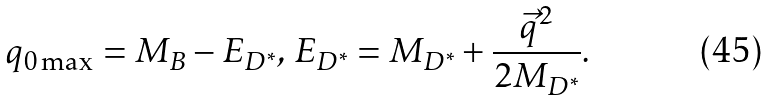Convert formula to latex. <formula><loc_0><loc_0><loc_500><loc_500>q _ { 0 \max } = M _ { B } - E _ { D ^ { * } } , \, E _ { D ^ { * } } = M _ { D ^ { * } } + \frac { { \vec { q } } ^ { 2 } } { 2 M _ { D ^ { * } } } .</formula> 